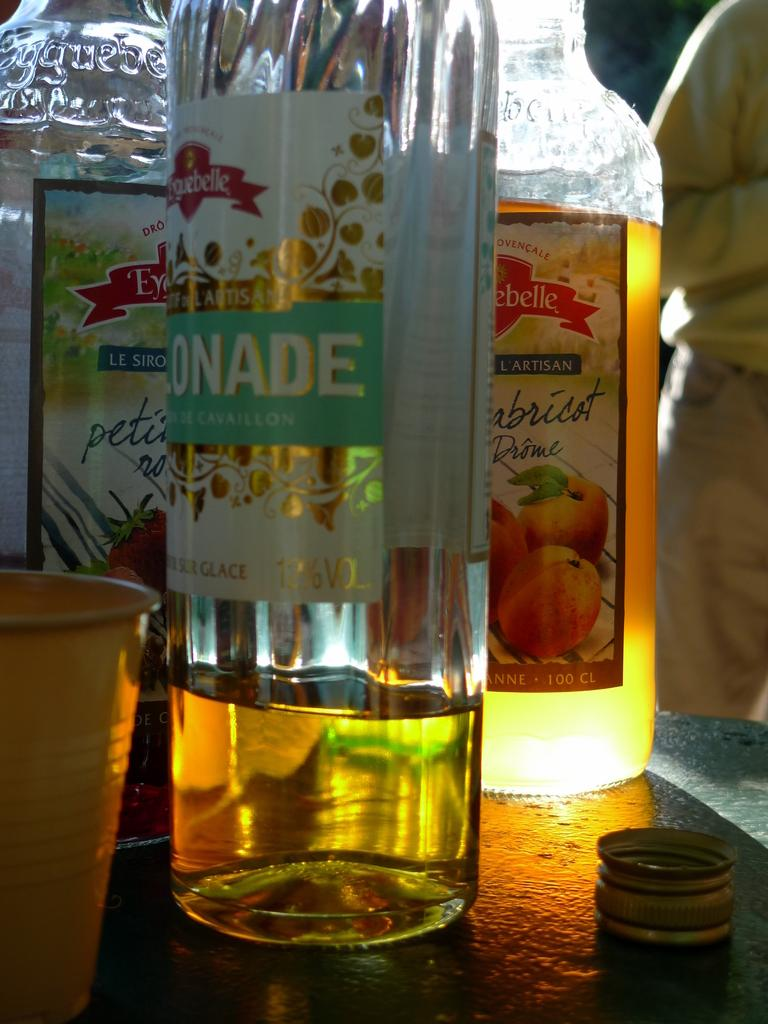How many bottles are visible in the image? There are three bottles in the image. What is written on the bottles? The bottles are labelled as 'LISTEN'. What other object can be seen in the image besides the bottles? There is a glass in the image. What else is present in the image that is not a bottle or a glass? There is a cap in the image. Can you describe the person in the image? A man is standing on the right side of the image. What type of ship can be seen sailing in the background of the image? There is no ship visible in the image; it only features bottles, a glass, a cap, and a man. Can you describe the monkey playing with the cap in the image? There is no monkey present in the image; the only living being is the man standing on the right side. 